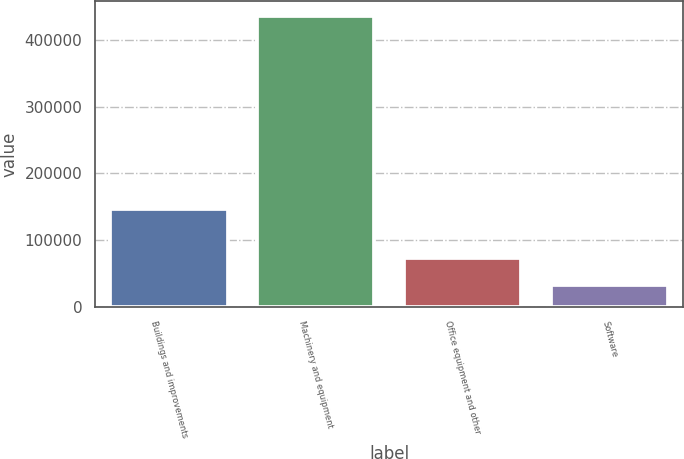<chart> <loc_0><loc_0><loc_500><loc_500><bar_chart><fcel>Buildings and improvements<fcel>Machinery and equipment<fcel>Office equipment and other<fcel>Software<nl><fcel>147114<fcel>436104<fcel>73612.8<fcel>33336<nl></chart> 